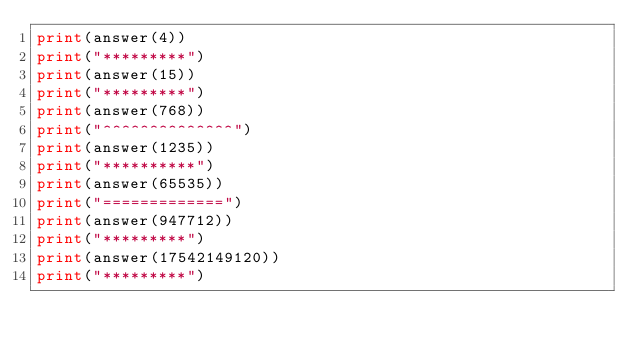<code> <loc_0><loc_0><loc_500><loc_500><_Python_>print(answer(4))
print("*********")
print(answer(15))
print("*********")
print(answer(768))
print("^^^^^^^^^^^^^^")
print(answer(1235))
print("**********")
print(answer(65535))
print("=============")
print(answer(947712))
print("*********")
print(answer(17542149120))
print("*********")</code> 